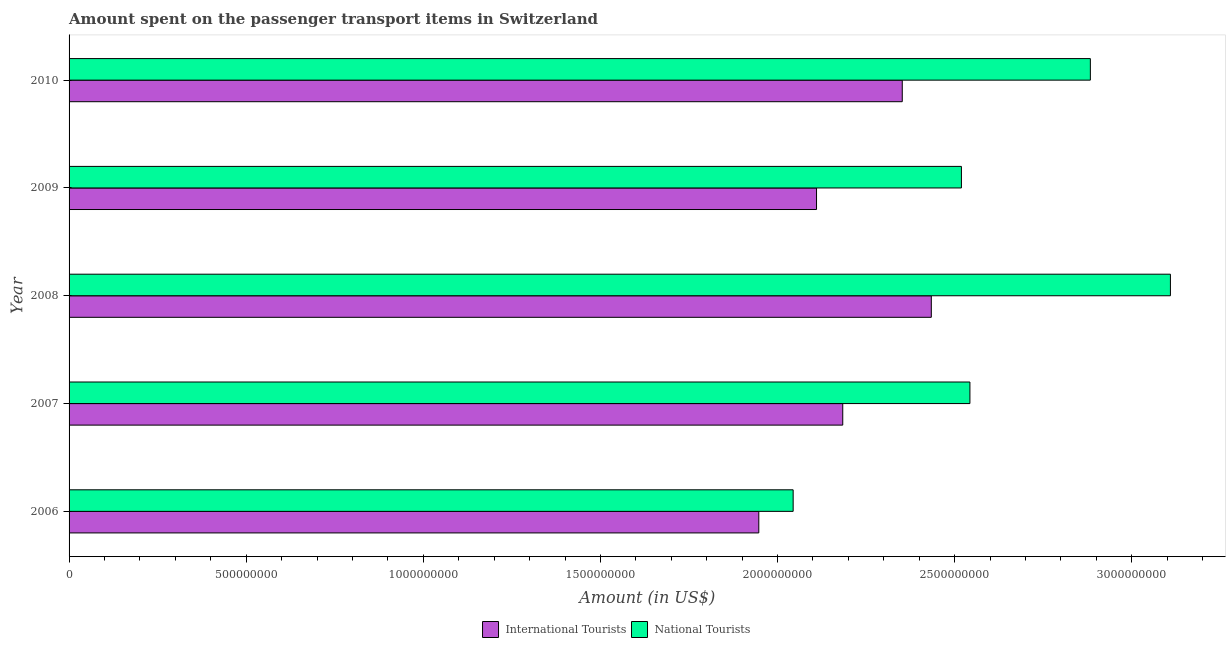Are the number of bars per tick equal to the number of legend labels?
Your answer should be very brief. Yes. What is the label of the 2nd group of bars from the top?
Provide a succinct answer. 2009. In how many cases, is the number of bars for a given year not equal to the number of legend labels?
Your response must be concise. 0. What is the amount spent on transport items of national tourists in 2007?
Provide a short and direct response. 2.54e+09. Across all years, what is the maximum amount spent on transport items of international tourists?
Offer a very short reply. 2.43e+09. Across all years, what is the minimum amount spent on transport items of international tourists?
Ensure brevity in your answer.  1.95e+09. In which year was the amount spent on transport items of international tourists maximum?
Ensure brevity in your answer.  2008. What is the total amount spent on transport items of international tourists in the graph?
Your answer should be very brief. 1.10e+1. What is the difference between the amount spent on transport items of international tourists in 2008 and that in 2010?
Provide a succinct answer. 8.20e+07. What is the difference between the amount spent on transport items of national tourists in 2008 and the amount spent on transport items of international tourists in 2009?
Ensure brevity in your answer.  9.99e+08. What is the average amount spent on transport items of national tourists per year?
Offer a terse response. 2.62e+09. In the year 2009, what is the difference between the amount spent on transport items of national tourists and amount spent on transport items of international tourists?
Offer a terse response. 4.09e+08. What is the ratio of the amount spent on transport items of international tourists in 2006 to that in 2010?
Offer a very short reply. 0.83. Is the difference between the amount spent on transport items of national tourists in 2007 and 2008 greater than the difference between the amount spent on transport items of international tourists in 2007 and 2008?
Keep it short and to the point. No. What is the difference between the highest and the second highest amount spent on transport items of international tourists?
Provide a succinct answer. 8.20e+07. What is the difference between the highest and the lowest amount spent on transport items of national tourists?
Give a very brief answer. 1.06e+09. In how many years, is the amount spent on transport items of national tourists greater than the average amount spent on transport items of national tourists taken over all years?
Give a very brief answer. 2. What does the 2nd bar from the top in 2006 represents?
Offer a terse response. International Tourists. What does the 2nd bar from the bottom in 2009 represents?
Your answer should be compact. National Tourists. How many bars are there?
Provide a succinct answer. 10. Are all the bars in the graph horizontal?
Offer a very short reply. Yes. What is the difference between two consecutive major ticks on the X-axis?
Offer a very short reply. 5.00e+08. What is the title of the graph?
Offer a very short reply. Amount spent on the passenger transport items in Switzerland. Does "Enforce a contract" appear as one of the legend labels in the graph?
Your answer should be compact. No. What is the label or title of the Y-axis?
Keep it short and to the point. Year. What is the Amount (in US$) in International Tourists in 2006?
Your answer should be very brief. 1.95e+09. What is the Amount (in US$) in National Tourists in 2006?
Offer a terse response. 2.04e+09. What is the Amount (in US$) of International Tourists in 2007?
Give a very brief answer. 2.18e+09. What is the Amount (in US$) of National Tourists in 2007?
Give a very brief answer. 2.54e+09. What is the Amount (in US$) of International Tourists in 2008?
Your answer should be very brief. 2.43e+09. What is the Amount (in US$) in National Tourists in 2008?
Provide a short and direct response. 3.11e+09. What is the Amount (in US$) in International Tourists in 2009?
Offer a terse response. 2.11e+09. What is the Amount (in US$) of National Tourists in 2009?
Provide a short and direct response. 2.52e+09. What is the Amount (in US$) of International Tourists in 2010?
Ensure brevity in your answer.  2.35e+09. What is the Amount (in US$) of National Tourists in 2010?
Offer a very short reply. 2.88e+09. Across all years, what is the maximum Amount (in US$) of International Tourists?
Make the answer very short. 2.43e+09. Across all years, what is the maximum Amount (in US$) in National Tourists?
Your answer should be very brief. 3.11e+09. Across all years, what is the minimum Amount (in US$) in International Tourists?
Provide a succinct answer. 1.95e+09. Across all years, what is the minimum Amount (in US$) in National Tourists?
Offer a very short reply. 2.04e+09. What is the total Amount (in US$) in International Tourists in the graph?
Make the answer very short. 1.10e+1. What is the total Amount (in US$) in National Tourists in the graph?
Make the answer very short. 1.31e+1. What is the difference between the Amount (in US$) in International Tourists in 2006 and that in 2007?
Provide a short and direct response. -2.37e+08. What is the difference between the Amount (in US$) in National Tourists in 2006 and that in 2007?
Provide a short and direct response. -4.99e+08. What is the difference between the Amount (in US$) in International Tourists in 2006 and that in 2008?
Ensure brevity in your answer.  -4.87e+08. What is the difference between the Amount (in US$) of National Tourists in 2006 and that in 2008?
Provide a succinct answer. -1.06e+09. What is the difference between the Amount (in US$) of International Tourists in 2006 and that in 2009?
Ensure brevity in your answer.  -1.63e+08. What is the difference between the Amount (in US$) in National Tourists in 2006 and that in 2009?
Ensure brevity in your answer.  -4.75e+08. What is the difference between the Amount (in US$) in International Tourists in 2006 and that in 2010?
Your answer should be compact. -4.05e+08. What is the difference between the Amount (in US$) in National Tourists in 2006 and that in 2010?
Offer a very short reply. -8.39e+08. What is the difference between the Amount (in US$) in International Tourists in 2007 and that in 2008?
Offer a terse response. -2.50e+08. What is the difference between the Amount (in US$) of National Tourists in 2007 and that in 2008?
Make the answer very short. -5.66e+08. What is the difference between the Amount (in US$) of International Tourists in 2007 and that in 2009?
Your answer should be very brief. 7.40e+07. What is the difference between the Amount (in US$) in National Tourists in 2007 and that in 2009?
Your response must be concise. 2.40e+07. What is the difference between the Amount (in US$) of International Tourists in 2007 and that in 2010?
Your response must be concise. -1.68e+08. What is the difference between the Amount (in US$) of National Tourists in 2007 and that in 2010?
Ensure brevity in your answer.  -3.40e+08. What is the difference between the Amount (in US$) in International Tourists in 2008 and that in 2009?
Offer a terse response. 3.24e+08. What is the difference between the Amount (in US$) in National Tourists in 2008 and that in 2009?
Make the answer very short. 5.90e+08. What is the difference between the Amount (in US$) in International Tourists in 2008 and that in 2010?
Keep it short and to the point. 8.20e+07. What is the difference between the Amount (in US$) of National Tourists in 2008 and that in 2010?
Provide a succinct answer. 2.26e+08. What is the difference between the Amount (in US$) of International Tourists in 2009 and that in 2010?
Provide a short and direct response. -2.42e+08. What is the difference between the Amount (in US$) in National Tourists in 2009 and that in 2010?
Give a very brief answer. -3.64e+08. What is the difference between the Amount (in US$) in International Tourists in 2006 and the Amount (in US$) in National Tourists in 2007?
Your response must be concise. -5.96e+08. What is the difference between the Amount (in US$) in International Tourists in 2006 and the Amount (in US$) in National Tourists in 2008?
Provide a short and direct response. -1.16e+09. What is the difference between the Amount (in US$) of International Tourists in 2006 and the Amount (in US$) of National Tourists in 2009?
Your answer should be very brief. -5.72e+08. What is the difference between the Amount (in US$) of International Tourists in 2006 and the Amount (in US$) of National Tourists in 2010?
Offer a terse response. -9.36e+08. What is the difference between the Amount (in US$) in International Tourists in 2007 and the Amount (in US$) in National Tourists in 2008?
Your response must be concise. -9.25e+08. What is the difference between the Amount (in US$) in International Tourists in 2007 and the Amount (in US$) in National Tourists in 2009?
Keep it short and to the point. -3.35e+08. What is the difference between the Amount (in US$) of International Tourists in 2007 and the Amount (in US$) of National Tourists in 2010?
Offer a very short reply. -6.99e+08. What is the difference between the Amount (in US$) of International Tourists in 2008 and the Amount (in US$) of National Tourists in 2009?
Your response must be concise. -8.50e+07. What is the difference between the Amount (in US$) of International Tourists in 2008 and the Amount (in US$) of National Tourists in 2010?
Offer a terse response. -4.49e+08. What is the difference between the Amount (in US$) in International Tourists in 2009 and the Amount (in US$) in National Tourists in 2010?
Offer a very short reply. -7.73e+08. What is the average Amount (in US$) of International Tourists per year?
Provide a succinct answer. 2.21e+09. What is the average Amount (in US$) of National Tourists per year?
Keep it short and to the point. 2.62e+09. In the year 2006, what is the difference between the Amount (in US$) of International Tourists and Amount (in US$) of National Tourists?
Your answer should be compact. -9.70e+07. In the year 2007, what is the difference between the Amount (in US$) of International Tourists and Amount (in US$) of National Tourists?
Your answer should be compact. -3.59e+08. In the year 2008, what is the difference between the Amount (in US$) of International Tourists and Amount (in US$) of National Tourists?
Keep it short and to the point. -6.75e+08. In the year 2009, what is the difference between the Amount (in US$) of International Tourists and Amount (in US$) of National Tourists?
Provide a short and direct response. -4.09e+08. In the year 2010, what is the difference between the Amount (in US$) in International Tourists and Amount (in US$) in National Tourists?
Offer a terse response. -5.31e+08. What is the ratio of the Amount (in US$) of International Tourists in 2006 to that in 2007?
Offer a terse response. 0.89. What is the ratio of the Amount (in US$) in National Tourists in 2006 to that in 2007?
Your answer should be very brief. 0.8. What is the ratio of the Amount (in US$) of International Tourists in 2006 to that in 2008?
Ensure brevity in your answer.  0.8. What is the ratio of the Amount (in US$) in National Tourists in 2006 to that in 2008?
Ensure brevity in your answer.  0.66. What is the ratio of the Amount (in US$) in International Tourists in 2006 to that in 2009?
Your answer should be compact. 0.92. What is the ratio of the Amount (in US$) of National Tourists in 2006 to that in 2009?
Offer a terse response. 0.81. What is the ratio of the Amount (in US$) of International Tourists in 2006 to that in 2010?
Your response must be concise. 0.83. What is the ratio of the Amount (in US$) in National Tourists in 2006 to that in 2010?
Make the answer very short. 0.71. What is the ratio of the Amount (in US$) in International Tourists in 2007 to that in 2008?
Give a very brief answer. 0.9. What is the ratio of the Amount (in US$) in National Tourists in 2007 to that in 2008?
Make the answer very short. 0.82. What is the ratio of the Amount (in US$) of International Tourists in 2007 to that in 2009?
Provide a short and direct response. 1.04. What is the ratio of the Amount (in US$) of National Tourists in 2007 to that in 2009?
Provide a short and direct response. 1.01. What is the ratio of the Amount (in US$) in National Tourists in 2007 to that in 2010?
Ensure brevity in your answer.  0.88. What is the ratio of the Amount (in US$) in International Tourists in 2008 to that in 2009?
Your response must be concise. 1.15. What is the ratio of the Amount (in US$) in National Tourists in 2008 to that in 2009?
Make the answer very short. 1.23. What is the ratio of the Amount (in US$) of International Tourists in 2008 to that in 2010?
Offer a very short reply. 1.03. What is the ratio of the Amount (in US$) in National Tourists in 2008 to that in 2010?
Provide a succinct answer. 1.08. What is the ratio of the Amount (in US$) in International Tourists in 2009 to that in 2010?
Give a very brief answer. 0.9. What is the ratio of the Amount (in US$) of National Tourists in 2009 to that in 2010?
Ensure brevity in your answer.  0.87. What is the difference between the highest and the second highest Amount (in US$) of International Tourists?
Keep it short and to the point. 8.20e+07. What is the difference between the highest and the second highest Amount (in US$) of National Tourists?
Your answer should be compact. 2.26e+08. What is the difference between the highest and the lowest Amount (in US$) in International Tourists?
Your answer should be compact. 4.87e+08. What is the difference between the highest and the lowest Amount (in US$) of National Tourists?
Offer a terse response. 1.06e+09. 